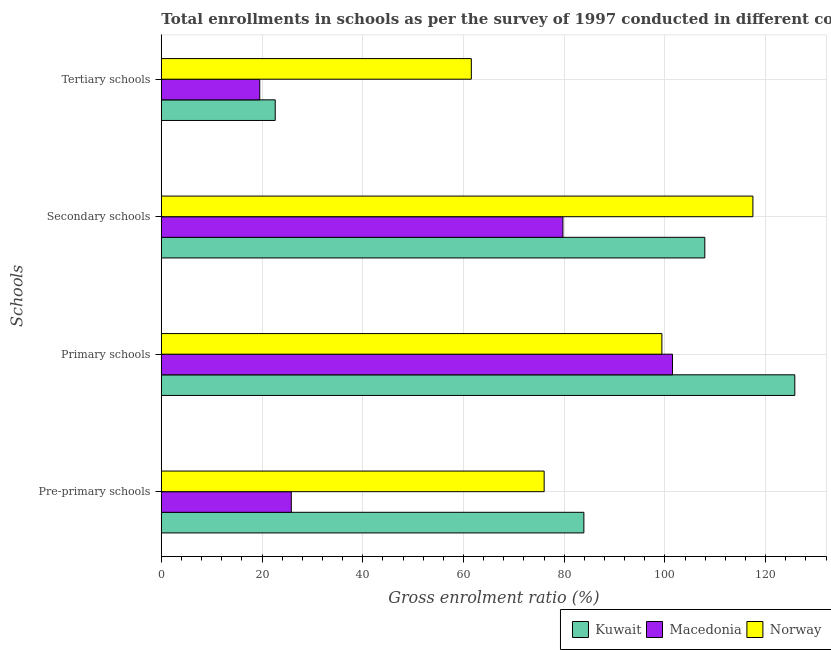How many different coloured bars are there?
Offer a very short reply. 3. Are the number of bars per tick equal to the number of legend labels?
Your answer should be very brief. Yes. How many bars are there on the 3rd tick from the top?
Ensure brevity in your answer.  3. What is the label of the 4th group of bars from the top?
Make the answer very short. Pre-primary schools. What is the gross enrolment ratio in tertiary schools in Macedonia?
Provide a succinct answer. 19.55. Across all countries, what is the maximum gross enrolment ratio in pre-primary schools?
Keep it short and to the point. 83.91. Across all countries, what is the minimum gross enrolment ratio in tertiary schools?
Keep it short and to the point. 19.55. In which country was the gross enrolment ratio in primary schools maximum?
Offer a terse response. Kuwait. In which country was the gross enrolment ratio in primary schools minimum?
Offer a very short reply. Norway. What is the total gross enrolment ratio in tertiary schools in the graph?
Keep it short and to the point. 103.73. What is the difference between the gross enrolment ratio in pre-primary schools in Norway and that in Kuwait?
Provide a succinct answer. -7.89. What is the difference between the gross enrolment ratio in secondary schools in Macedonia and the gross enrolment ratio in tertiary schools in Norway?
Make the answer very short. 18.19. What is the average gross enrolment ratio in pre-primary schools per country?
Make the answer very short. 61.92. What is the difference between the gross enrolment ratio in tertiary schools and gross enrolment ratio in secondary schools in Macedonia?
Give a very brief answer. -60.21. In how many countries, is the gross enrolment ratio in secondary schools greater than 8 %?
Provide a short and direct response. 3. What is the ratio of the gross enrolment ratio in secondary schools in Kuwait to that in Macedonia?
Your response must be concise. 1.35. Is the gross enrolment ratio in tertiary schools in Norway less than that in Kuwait?
Ensure brevity in your answer.  No. Is the difference between the gross enrolment ratio in tertiary schools in Kuwait and Norway greater than the difference between the gross enrolment ratio in secondary schools in Kuwait and Norway?
Offer a terse response. No. What is the difference between the highest and the second highest gross enrolment ratio in tertiary schools?
Provide a succinct answer. 38.94. What is the difference between the highest and the lowest gross enrolment ratio in primary schools?
Provide a succinct answer. 26.4. In how many countries, is the gross enrolment ratio in pre-primary schools greater than the average gross enrolment ratio in pre-primary schools taken over all countries?
Offer a terse response. 2. Is it the case that in every country, the sum of the gross enrolment ratio in primary schools and gross enrolment ratio in secondary schools is greater than the sum of gross enrolment ratio in pre-primary schools and gross enrolment ratio in tertiary schools?
Offer a very short reply. No. What does the 1st bar from the top in Tertiary schools represents?
Keep it short and to the point. Norway. Is it the case that in every country, the sum of the gross enrolment ratio in pre-primary schools and gross enrolment ratio in primary schools is greater than the gross enrolment ratio in secondary schools?
Offer a terse response. Yes. How many bars are there?
Provide a succinct answer. 12. Are all the bars in the graph horizontal?
Keep it short and to the point. Yes. How many countries are there in the graph?
Offer a terse response. 3. Does the graph contain any zero values?
Provide a short and direct response. No. Does the graph contain grids?
Your response must be concise. Yes. Where does the legend appear in the graph?
Ensure brevity in your answer.  Bottom right. What is the title of the graph?
Give a very brief answer. Total enrollments in schools as per the survey of 1997 conducted in different countries. Does "Netherlands" appear as one of the legend labels in the graph?
Ensure brevity in your answer.  No. What is the label or title of the Y-axis?
Give a very brief answer. Schools. What is the Gross enrolment ratio (%) in Kuwait in Pre-primary schools?
Your answer should be very brief. 83.91. What is the Gross enrolment ratio (%) in Macedonia in Pre-primary schools?
Ensure brevity in your answer.  25.81. What is the Gross enrolment ratio (%) of Norway in Pre-primary schools?
Provide a succinct answer. 76.03. What is the Gross enrolment ratio (%) in Kuwait in Primary schools?
Keep it short and to the point. 125.81. What is the Gross enrolment ratio (%) in Macedonia in Primary schools?
Make the answer very short. 101.51. What is the Gross enrolment ratio (%) of Norway in Primary schools?
Offer a very short reply. 99.41. What is the Gross enrolment ratio (%) in Kuwait in Secondary schools?
Provide a short and direct response. 107.93. What is the Gross enrolment ratio (%) of Macedonia in Secondary schools?
Give a very brief answer. 79.75. What is the Gross enrolment ratio (%) in Norway in Secondary schools?
Give a very brief answer. 117.48. What is the Gross enrolment ratio (%) of Kuwait in Tertiary schools?
Provide a succinct answer. 22.62. What is the Gross enrolment ratio (%) of Macedonia in Tertiary schools?
Keep it short and to the point. 19.55. What is the Gross enrolment ratio (%) of Norway in Tertiary schools?
Keep it short and to the point. 61.56. Across all Schools, what is the maximum Gross enrolment ratio (%) in Kuwait?
Offer a terse response. 125.81. Across all Schools, what is the maximum Gross enrolment ratio (%) of Macedonia?
Offer a very short reply. 101.51. Across all Schools, what is the maximum Gross enrolment ratio (%) of Norway?
Offer a very short reply. 117.48. Across all Schools, what is the minimum Gross enrolment ratio (%) of Kuwait?
Offer a terse response. 22.62. Across all Schools, what is the minimum Gross enrolment ratio (%) of Macedonia?
Provide a succinct answer. 19.55. Across all Schools, what is the minimum Gross enrolment ratio (%) in Norway?
Ensure brevity in your answer.  61.56. What is the total Gross enrolment ratio (%) in Kuwait in the graph?
Your response must be concise. 340.27. What is the total Gross enrolment ratio (%) in Macedonia in the graph?
Provide a short and direct response. 226.63. What is the total Gross enrolment ratio (%) of Norway in the graph?
Your response must be concise. 354.48. What is the difference between the Gross enrolment ratio (%) of Kuwait in Pre-primary schools and that in Primary schools?
Offer a very short reply. -41.89. What is the difference between the Gross enrolment ratio (%) of Macedonia in Pre-primary schools and that in Primary schools?
Keep it short and to the point. -75.7. What is the difference between the Gross enrolment ratio (%) of Norway in Pre-primary schools and that in Primary schools?
Keep it short and to the point. -23.38. What is the difference between the Gross enrolment ratio (%) in Kuwait in Pre-primary schools and that in Secondary schools?
Make the answer very short. -24.02. What is the difference between the Gross enrolment ratio (%) of Macedonia in Pre-primary schools and that in Secondary schools?
Your answer should be compact. -53.94. What is the difference between the Gross enrolment ratio (%) of Norway in Pre-primary schools and that in Secondary schools?
Keep it short and to the point. -41.45. What is the difference between the Gross enrolment ratio (%) of Kuwait in Pre-primary schools and that in Tertiary schools?
Provide a short and direct response. 61.29. What is the difference between the Gross enrolment ratio (%) in Macedonia in Pre-primary schools and that in Tertiary schools?
Your response must be concise. 6.27. What is the difference between the Gross enrolment ratio (%) in Norway in Pre-primary schools and that in Tertiary schools?
Your response must be concise. 14.46. What is the difference between the Gross enrolment ratio (%) in Kuwait in Primary schools and that in Secondary schools?
Your response must be concise. 17.87. What is the difference between the Gross enrolment ratio (%) of Macedonia in Primary schools and that in Secondary schools?
Keep it short and to the point. 21.76. What is the difference between the Gross enrolment ratio (%) of Norway in Primary schools and that in Secondary schools?
Your response must be concise. -18.08. What is the difference between the Gross enrolment ratio (%) in Kuwait in Primary schools and that in Tertiary schools?
Offer a very short reply. 103.18. What is the difference between the Gross enrolment ratio (%) in Macedonia in Primary schools and that in Tertiary schools?
Keep it short and to the point. 81.97. What is the difference between the Gross enrolment ratio (%) in Norway in Primary schools and that in Tertiary schools?
Ensure brevity in your answer.  37.84. What is the difference between the Gross enrolment ratio (%) of Kuwait in Secondary schools and that in Tertiary schools?
Offer a terse response. 85.31. What is the difference between the Gross enrolment ratio (%) of Macedonia in Secondary schools and that in Tertiary schools?
Your answer should be compact. 60.21. What is the difference between the Gross enrolment ratio (%) in Norway in Secondary schools and that in Tertiary schools?
Offer a very short reply. 55.92. What is the difference between the Gross enrolment ratio (%) of Kuwait in Pre-primary schools and the Gross enrolment ratio (%) of Macedonia in Primary schools?
Offer a terse response. -17.6. What is the difference between the Gross enrolment ratio (%) of Kuwait in Pre-primary schools and the Gross enrolment ratio (%) of Norway in Primary schools?
Provide a succinct answer. -15.49. What is the difference between the Gross enrolment ratio (%) in Macedonia in Pre-primary schools and the Gross enrolment ratio (%) in Norway in Primary schools?
Make the answer very short. -73.59. What is the difference between the Gross enrolment ratio (%) of Kuwait in Pre-primary schools and the Gross enrolment ratio (%) of Macedonia in Secondary schools?
Offer a terse response. 4.16. What is the difference between the Gross enrolment ratio (%) in Kuwait in Pre-primary schools and the Gross enrolment ratio (%) in Norway in Secondary schools?
Make the answer very short. -33.57. What is the difference between the Gross enrolment ratio (%) in Macedonia in Pre-primary schools and the Gross enrolment ratio (%) in Norway in Secondary schools?
Offer a very short reply. -91.67. What is the difference between the Gross enrolment ratio (%) of Kuwait in Pre-primary schools and the Gross enrolment ratio (%) of Macedonia in Tertiary schools?
Make the answer very short. 64.37. What is the difference between the Gross enrolment ratio (%) of Kuwait in Pre-primary schools and the Gross enrolment ratio (%) of Norway in Tertiary schools?
Provide a short and direct response. 22.35. What is the difference between the Gross enrolment ratio (%) in Macedonia in Pre-primary schools and the Gross enrolment ratio (%) in Norway in Tertiary schools?
Offer a very short reply. -35.75. What is the difference between the Gross enrolment ratio (%) of Kuwait in Primary schools and the Gross enrolment ratio (%) of Macedonia in Secondary schools?
Your answer should be very brief. 46.05. What is the difference between the Gross enrolment ratio (%) in Kuwait in Primary schools and the Gross enrolment ratio (%) in Norway in Secondary schools?
Your answer should be compact. 8.32. What is the difference between the Gross enrolment ratio (%) in Macedonia in Primary schools and the Gross enrolment ratio (%) in Norway in Secondary schools?
Provide a short and direct response. -15.97. What is the difference between the Gross enrolment ratio (%) of Kuwait in Primary schools and the Gross enrolment ratio (%) of Macedonia in Tertiary schools?
Your answer should be very brief. 106.26. What is the difference between the Gross enrolment ratio (%) of Kuwait in Primary schools and the Gross enrolment ratio (%) of Norway in Tertiary schools?
Ensure brevity in your answer.  64.24. What is the difference between the Gross enrolment ratio (%) of Macedonia in Primary schools and the Gross enrolment ratio (%) of Norway in Tertiary schools?
Provide a short and direct response. 39.95. What is the difference between the Gross enrolment ratio (%) in Kuwait in Secondary schools and the Gross enrolment ratio (%) in Macedonia in Tertiary schools?
Your answer should be very brief. 88.39. What is the difference between the Gross enrolment ratio (%) in Kuwait in Secondary schools and the Gross enrolment ratio (%) in Norway in Tertiary schools?
Give a very brief answer. 46.37. What is the difference between the Gross enrolment ratio (%) of Macedonia in Secondary schools and the Gross enrolment ratio (%) of Norway in Tertiary schools?
Provide a short and direct response. 18.19. What is the average Gross enrolment ratio (%) in Kuwait per Schools?
Provide a succinct answer. 85.07. What is the average Gross enrolment ratio (%) in Macedonia per Schools?
Your answer should be compact. 56.66. What is the average Gross enrolment ratio (%) in Norway per Schools?
Make the answer very short. 88.62. What is the difference between the Gross enrolment ratio (%) of Kuwait and Gross enrolment ratio (%) of Macedonia in Pre-primary schools?
Provide a short and direct response. 58.1. What is the difference between the Gross enrolment ratio (%) of Kuwait and Gross enrolment ratio (%) of Norway in Pre-primary schools?
Your response must be concise. 7.89. What is the difference between the Gross enrolment ratio (%) in Macedonia and Gross enrolment ratio (%) in Norway in Pre-primary schools?
Your response must be concise. -50.21. What is the difference between the Gross enrolment ratio (%) of Kuwait and Gross enrolment ratio (%) of Macedonia in Primary schools?
Your response must be concise. 24.29. What is the difference between the Gross enrolment ratio (%) in Kuwait and Gross enrolment ratio (%) in Norway in Primary schools?
Offer a terse response. 26.4. What is the difference between the Gross enrolment ratio (%) in Macedonia and Gross enrolment ratio (%) in Norway in Primary schools?
Your response must be concise. 2.11. What is the difference between the Gross enrolment ratio (%) of Kuwait and Gross enrolment ratio (%) of Macedonia in Secondary schools?
Make the answer very short. 28.18. What is the difference between the Gross enrolment ratio (%) in Kuwait and Gross enrolment ratio (%) in Norway in Secondary schools?
Make the answer very short. -9.55. What is the difference between the Gross enrolment ratio (%) in Macedonia and Gross enrolment ratio (%) in Norway in Secondary schools?
Make the answer very short. -37.73. What is the difference between the Gross enrolment ratio (%) of Kuwait and Gross enrolment ratio (%) of Macedonia in Tertiary schools?
Keep it short and to the point. 3.07. What is the difference between the Gross enrolment ratio (%) of Kuwait and Gross enrolment ratio (%) of Norway in Tertiary schools?
Ensure brevity in your answer.  -38.94. What is the difference between the Gross enrolment ratio (%) of Macedonia and Gross enrolment ratio (%) of Norway in Tertiary schools?
Provide a short and direct response. -42.02. What is the ratio of the Gross enrolment ratio (%) in Kuwait in Pre-primary schools to that in Primary schools?
Your answer should be very brief. 0.67. What is the ratio of the Gross enrolment ratio (%) in Macedonia in Pre-primary schools to that in Primary schools?
Keep it short and to the point. 0.25. What is the ratio of the Gross enrolment ratio (%) in Norway in Pre-primary schools to that in Primary schools?
Offer a terse response. 0.76. What is the ratio of the Gross enrolment ratio (%) in Kuwait in Pre-primary schools to that in Secondary schools?
Make the answer very short. 0.78. What is the ratio of the Gross enrolment ratio (%) of Macedonia in Pre-primary schools to that in Secondary schools?
Your answer should be very brief. 0.32. What is the ratio of the Gross enrolment ratio (%) of Norway in Pre-primary schools to that in Secondary schools?
Your response must be concise. 0.65. What is the ratio of the Gross enrolment ratio (%) of Kuwait in Pre-primary schools to that in Tertiary schools?
Provide a short and direct response. 3.71. What is the ratio of the Gross enrolment ratio (%) of Macedonia in Pre-primary schools to that in Tertiary schools?
Offer a terse response. 1.32. What is the ratio of the Gross enrolment ratio (%) in Norway in Pre-primary schools to that in Tertiary schools?
Your answer should be very brief. 1.23. What is the ratio of the Gross enrolment ratio (%) in Kuwait in Primary schools to that in Secondary schools?
Your answer should be compact. 1.17. What is the ratio of the Gross enrolment ratio (%) of Macedonia in Primary schools to that in Secondary schools?
Your response must be concise. 1.27. What is the ratio of the Gross enrolment ratio (%) of Norway in Primary schools to that in Secondary schools?
Ensure brevity in your answer.  0.85. What is the ratio of the Gross enrolment ratio (%) in Kuwait in Primary schools to that in Tertiary schools?
Offer a terse response. 5.56. What is the ratio of the Gross enrolment ratio (%) in Macedonia in Primary schools to that in Tertiary schools?
Your answer should be compact. 5.19. What is the ratio of the Gross enrolment ratio (%) of Norway in Primary schools to that in Tertiary schools?
Provide a short and direct response. 1.61. What is the ratio of the Gross enrolment ratio (%) in Kuwait in Secondary schools to that in Tertiary schools?
Your response must be concise. 4.77. What is the ratio of the Gross enrolment ratio (%) in Macedonia in Secondary schools to that in Tertiary schools?
Your answer should be compact. 4.08. What is the ratio of the Gross enrolment ratio (%) in Norway in Secondary schools to that in Tertiary schools?
Make the answer very short. 1.91. What is the difference between the highest and the second highest Gross enrolment ratio (%) in Kuwait?
Provide a succinct answer. 17.87. What is the difference between the highest and the second highest Gross enrolment ratio (%) in Macedonia?
Offer a terse response. 21.76. What is the difference between the highest and the second highest Gross enrolment ratio (%) in Norway?
Offer a terse response. 18.08. What is the difference between the highest and the lowest Gross enrolment ratio (%) in Kuwait?
Provide a succinct answer. 103.18. What is the difference between the highest and the lowest Gross enrolment ratio (%) in Macedonia?
Your response must be concise. 81.97. What is the difference between the highest and the lowest Gross enrolment ratio (%) in Norway?
Your response must be concise. 55.92. 